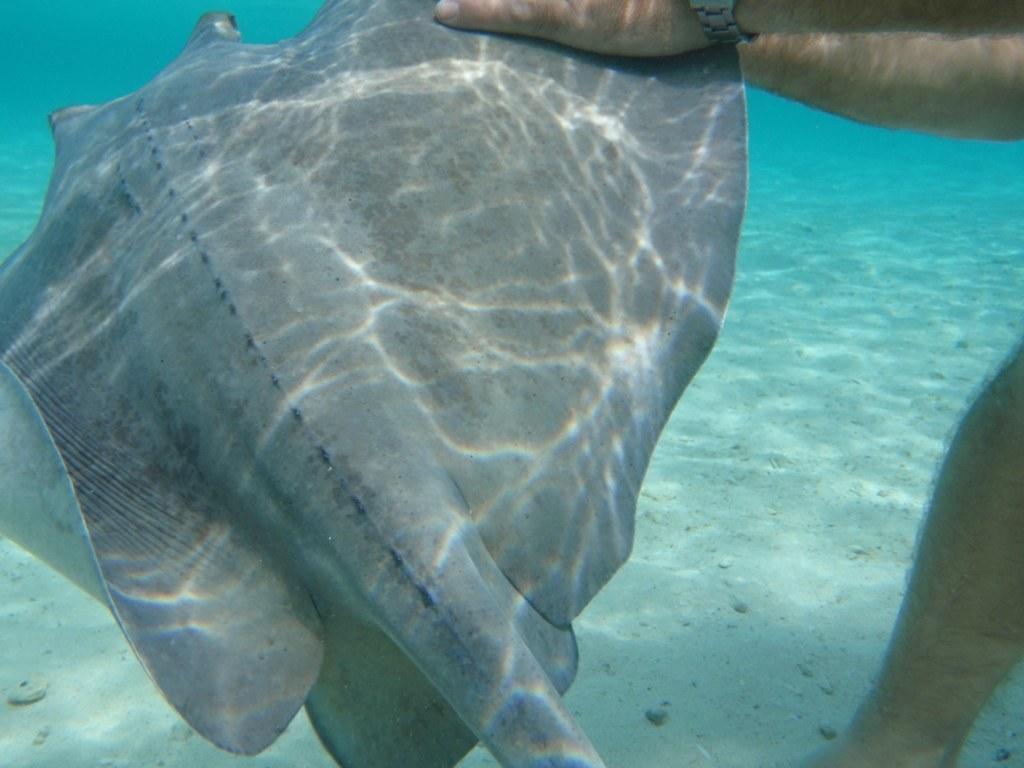Please provide a concise description of this image. In this image there is a starfish in a person's hand in the water, on the right side of the image there is a leg of a person. 